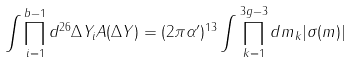<formula> <loc_0><loc_0><loc_500><loc_500>\int \prod _ { i = 1 } ^ { b - 1 } d ^ { 2 6 } \Delta Y _ { i } A ( \Delta Y ) = ( 2 \pi \alpha ^ { \prime } ) ^ { 1 3 } \int \prod _ { k = 1 } ^ { 3 g - 3 } d m _ { k } | \sigma ( m ) |</formula> 